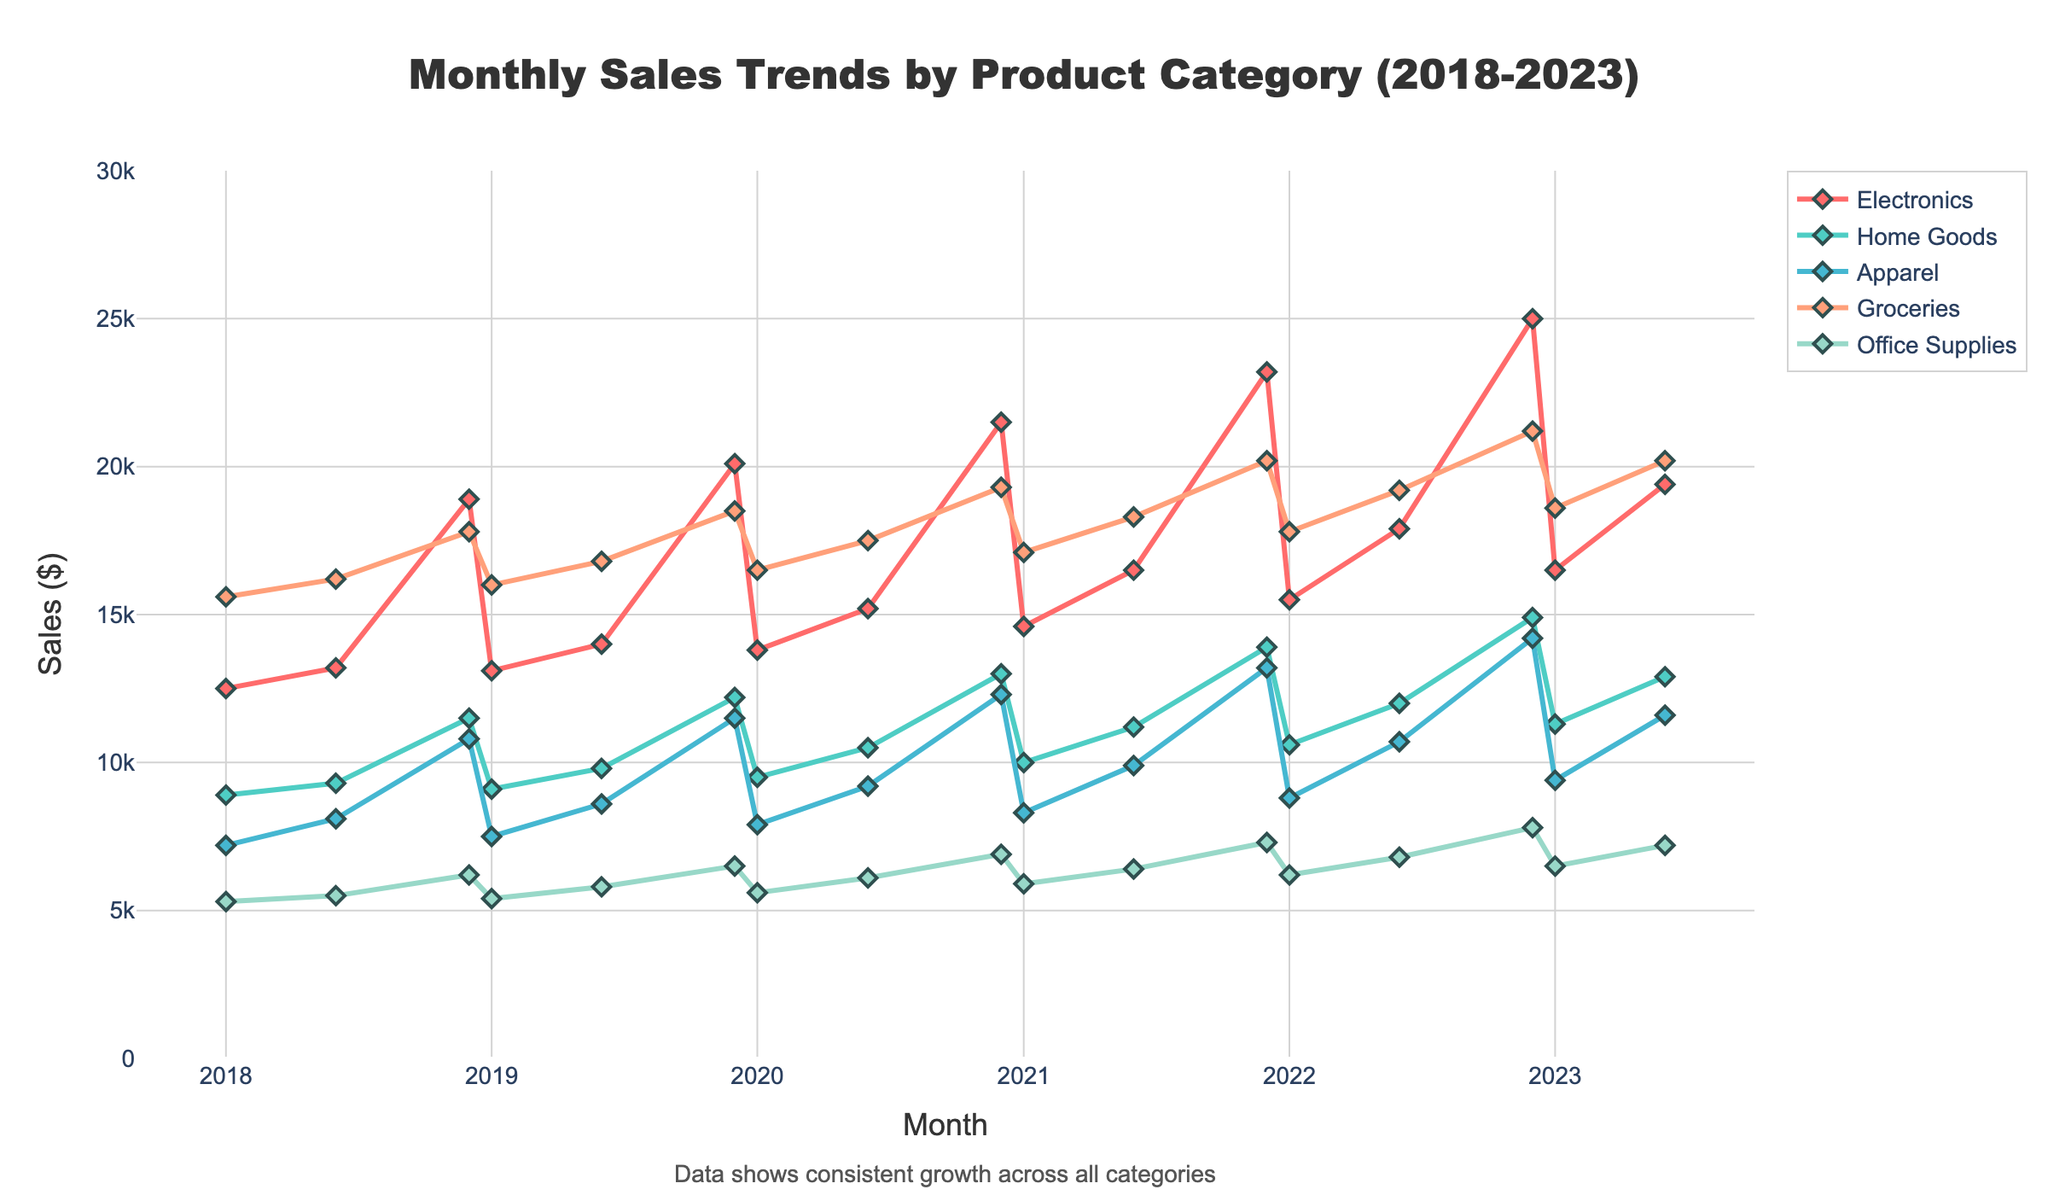Which product category had the highest sales in Dec 2022? Look at the sales values for all product categories in December 2022 and identify the highest one. Electronics had the highest value of 25000.
Answer: Electronics In which month did Home Goods see the sharpest increase in sales from the previous month shown? Compare the sales values of Home Goods across successive months and find the month with the largest difference. The increase from Jun to Dec in 2020 is 13000 - 10500 = 2500, which is the sharpest rise.
Answer: Dec 2020 What is the average sales value for Groceries over the entire period? Sum all the sales values for Groceries and divide by the number of months. (15600 + 16200 + 17800 + 16000 + 16800 + 18500 + 16500 + 17500 + 19300 + 17100 + 18300 + 20200 + 17800 + 19200 + 21200 + 18600 + 20200) / 17 = 17929
Answer: 17929 Which product category has the lowest variability in sales over the 5 years? Identify the category with the most stable trend line, having the smallest fluctuations. Office Supplies shows a relatively stable trend with the least fluctuation.
Answer: Office Supplies By how much did Electronics sales increase from Jun 2021 to Dec 2021? Subtract the sales value of Electronics in Jun 2021 from that in Dec 2021. 23200 - 16500 = 6700
Answer: 6700 Which two product categories had the closest sales values in Jan 2023? Compare the sales values of all product categories in Jan 2023 and find the two with the smallest difference. Apparel and Home Goods have sales values of 9400 and 11300 respectively, difference is 11300 - 9400 = 1900, which is the smallest.
Answer: Apparel and Home Goods What trend is observed in Apparel sales from Jan 2018 to Dec 2022? Examine the Apparel sales trend line from Jan 2018 to Dec 2022. The sales show a generally increasing trend from 7200 to 14200 over the years.
Answer: Increasing trend What is the difference in sales between Groceries and Office Supplies in Dec 2021? Subtract the sales value of Office Supplies from that of Groceries in Dec 2021. 20200 - 7300 = 12900
Answer: 12900 Which category shows the most significant sales peak in the data provided? Identify the category with the highest single peak in sales across the given timeline. Electronics in Dec 2022 with sales of 25000 is the most significant peak.
Answer: Electronics Compare the sales trajectory of Home Goods and Apparel from 2018 to 2023. What is the key difference? Analyze the lines for Home Goods and Apparel for any differences in their trends over the years. Home Goods show a steadier increase with fewer fluctuations, while Apparel has more oscillations.
Answer: Home Goods steady, Apparel oscillates 